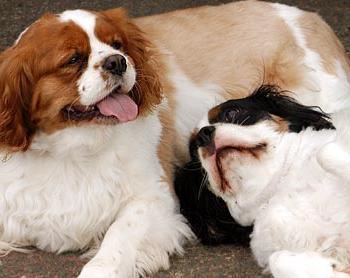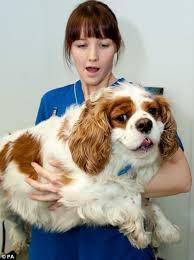The first image is the image on the left, the second image is the image on the right. Analyze the images presented: Is the assertion "One image contains a brown-and-white spaniel next to a dog with darker markings, and the other image contains only one brown-and-white spaniel." valid? Answer yes or no. Yes. The first image is the image on the left, the second image is the image on the right. Assess this claim about the two images: "There are exactly two dogs in the left image.". Correct or not? Answer yes or no. Yes. 